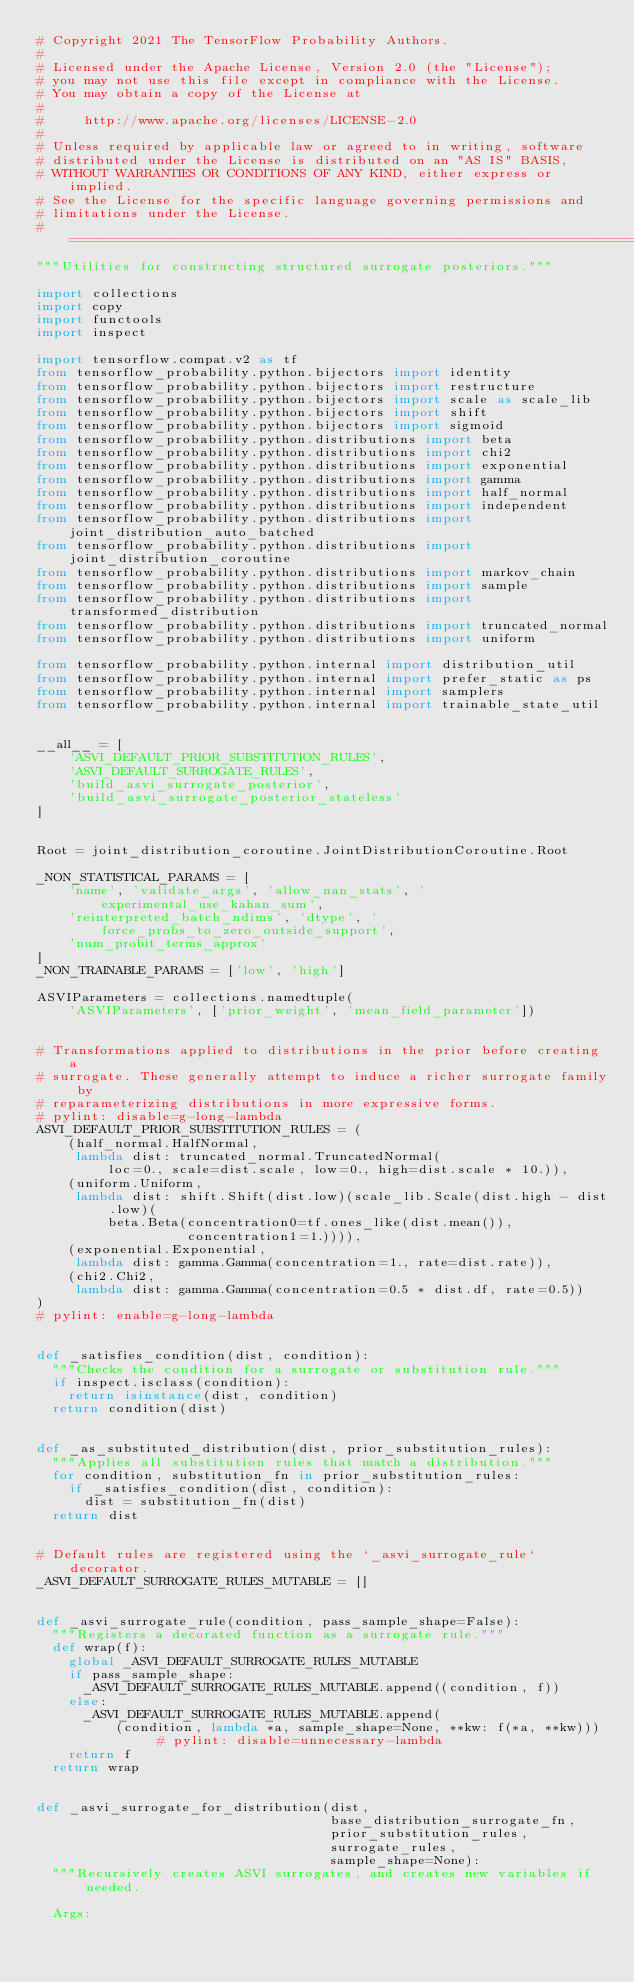<code> <loc_0><loc_0><loc_500><loc_500><_Python_># Copyright 2021 The TensorFlow Probability Authors.
#
# Licensed under the Apache License, Version 2.0 (the "License");
# you may not use this file except in compliance with the License.
# You may obtain a copy of the License at
#
#     http://www.apache.org/licenses/LICENSE-2.0
#
# Unless required by applicable law or agreed to in writing, software
# distributed under the License is distributed on an "AS IS" BASIS,
# WITHOUT WARRANTIES OR CONDITIONS OF ANY KIND, either express or implied.
# See the License for the specific language governing permissions and
# limitations under the License.
# ============================================================================
"""Utilities for constructing structured surrogate posteriors."""

import collections
import copy
import functools
import inspect

import tensorflow.compat.v2 as tf
from tensorflow_probability.python.bijectors import identity
from tensorflow_probability.python.bijectors import restructure
from tensorflow_probability.python.bijectors import scale as scale_lib
from tensorflow_probability.python.bijectors import shift
from tensorflow_probability.python.bijectors import sigmoid
from tensorflow_probability.python.distributions import beta
from tensorflow_probability.python.distributions import chi2
from tensorflow_probability.python.distributions import exponential
from tensorflow_probability.python.distributions import gamma
from tensorflow_probability.python.distributions import half_normal
from tensorflow_probability.python.distributions import independent
from tensorflow_probability.python.distributions import joint_distribution_auto_batched
from tensorflow_probability.python.distributions import joint_distribution_coroutine
from tensorflow_probability.python.distributions import markov_chain
from tensorflow_probability.python.distributions import sample
from tensorflow_probability.python.distributions import transformed_distribution
from tensorflow_probability.python.distributions import truncated_normal
from tensorflow_probability.python.distributions import uniform

from tensorflow_probability.python.internal import distribution_util
from tensorflow_probability.python.internal import prefer_static as ps
from tensorflow_probability.python.internal import samplers
from tensorflow_probability.python.internal import trainable_state_util


__all__ = [
    'ASVI_DEFAULT_PRIOR_SUBSTITUTION_RULES',
    'ASVI_DEFAULT_SURROGATE_RULES',
    'build_asvi_surrogate_posterior',
    'build_asvi_surrogate_posterior_stateless'
]


Root = joint_distribution_coroutine.JointDistributionCoroutine.Root

_NON_STATISTICAL_PARAMS = [
    'name', 'validate_args', 'allow_nan_stats', 'experimental_use_kahan_sum',
    'reinterpreted_batch_ndims', 'dtype', 'force_probs_to_zero_outside_support',
    'num_probit_terms_approx'
]
_NON_TRAINABLE_PARAMS = ['low', 'high']

ASVIParameters = collections.namedtuple(
    'ASVIParameters', ['prior_weight', 'mean_field_parameter'])


# Transformations applied to distributions in the prior before creating a
# surrogate. These generally attempt to induce a richer surrogate family by
# reparameterizing distributions in more expressive forms.
# pylint: disable=g-long-lambda
ASVI_DEFAULT_PRIOR_SUBSTITUTION_RULES = (
    (half_normal.HalfNormal,
     lambda dist: truncated_normal.TruncatedNormal(
         loc=0., scale=dist.scale, low=0., high=dist.scale * 10.)),
    (uniform.Uniform,
     lambda dist: shift.Shift(dist.low)(scale_lib.Scale(dist.high - dist.low)(
         beta.Beta(concentration0=tf.ones_like(dist.mean()),
                   concentration1=1.)))),
    (exponential.Exponential,
     lambda dist: gamma.Gamma(concentration=1., rate=dist.rate)),
    (chi2.Chi2,
     lambda dist: gamma.Gamma(concentration=0.5 * dist.df, rate=0.5))
)
# pylint: enable=g-long-lambda


def _satisfies_condition(dist, condition):
  """Checks the condition for a surrogate or substitution rule."""
  if inspect.isclass(condition):
    return isinstance(dist, condition)
  return condition(dist)


def _as_substituted_distribution(dist, prior_substitution_rules):
  """Applies all substitution rules that match a distribution."""
  for condition, substitution_fn in prior_substitution_rules:
    if _satisfies_condition(dist, condition):
      dist = substitution_fn(dist)
  return dist


# Default rules are registered using the `_asvi_surrogate_rule` decorator.
_ASVI_DEFAULT_SURROGATE_RULES_MUTABLE = []


def _asvi_surrogate_rule(condition, pass_sample_shape=False):
  """Registers a decorated function as a surrogate rule."""
  def wrap(f):
    global _ASVI_DEFAULT_SURROGATE_RULES_MUTABLE
    if pass_sample_shape:
      _ASVI_DEFAULT_SURROGATE_RULES_MUTABLE.append((condition, f))
    else:
      _ASVI_DEFAULT_SURROGATE_RULES_MUTABLE.append(
          (condition, lambda *a, sample_shape=None, **kw: f(*a, **kw)))  # pylint: disable=unnecessary-lambda
    return f
  return wrap


def _asvi_surrogate_for_distribution(dist,
                                     base_distribution_surrogate_fn,
                                     prior_substitution_rules,
                                     surrogate_rules,
                                     sample_shape=None):
  """Recursively creates ASVI surrogates, and creates new variables if needed.

  Args:</code> 